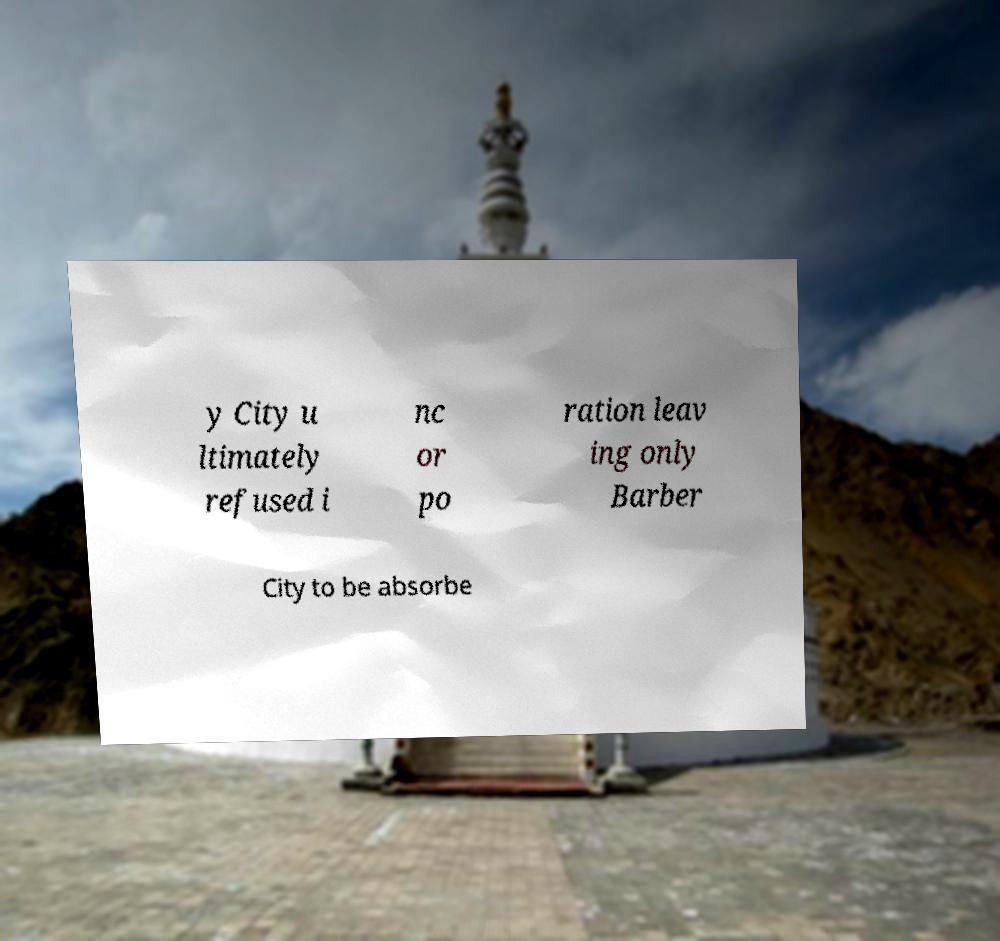Could you extract and type out the text from this image? y City u ltimately refused i nc or po ration leav ing only Barber City to be absorbe 